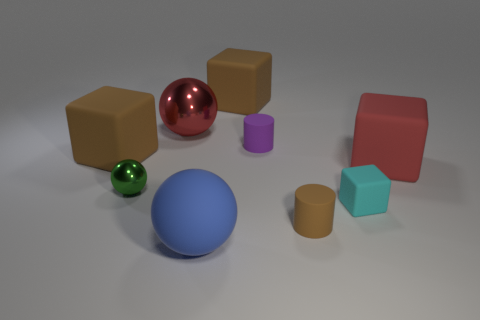What size is the cyan matte block?
Your answer should be compact. Small. What number of other things are there of the same color as the large shiny object?
Your answer should be compact. 1. Is the shape of the big object that is in front of the large red matte cube the same as  the red rubber object?
Give a very brief answer. No. The small shiny thing that is the same shape as the large red metal thing is what color?
Make the answer very short. Green. Are there any other things that have the same material as the tiny brown cylinder?
Keep it short and to the point. Yes. The red thing that is the same shape as the blue rubber thing is what size?
Your response must be concise. Large. What is the material of the cube that is in front of the large shiny thing and behind the big red matte block?
Ensure brevity in your answer.  Rubber. Is the color of the big cube that is behind the large metal thing the same as the tiny shiny sphere?
Provide a short and direct response. No. Do the small rubber block and the rubber block left of the large blue matte sphere have the same color?
Your answer should be compact. No. Are there any blue objects behind the small cyan matte thing?
Ensure brevity in your answer.  No. 